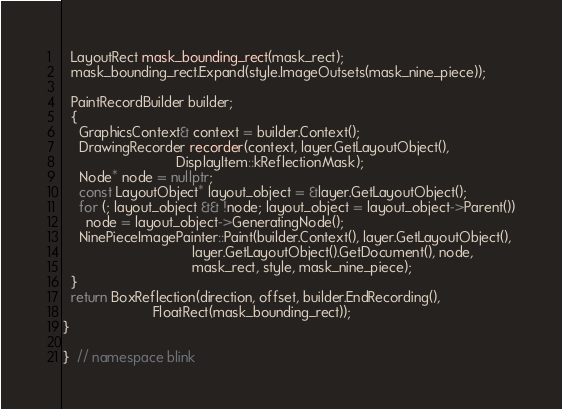<code> <loc_0><loc_0><loc_500><loc_500><_C++_>  LayoutRect mask_bounding_rect(mask_rect);
  mask_bounding_rect.Expand(style.ImageOutsets(mask_nine_piece));

  PaintRecordBuilder builder;
  {
    GraphicsContext& context = builder.Context();
    DrawingRecorder recorder(context, layer.GetLayoutObject(),
                             DisplayItem::kReflectionMask);
    Node* node = nullptr;
    const LayoutObject* layout_object = &layer.GetLayoutObject();
    for (; layout_object && !node; layout_object = layout_object->Parent())
      node = layout_object->GeneratingNode();
    NinePieceImagePainter::Paint(builder.Context(), layer.GetLayoutObject(),
                                 layer.GetLayoutObject().GetDocument(), node,
                                 mask_rect, style, mask_nine_piece);
  }
  return BoxReflection(direction, offset, builder.EndRecording(),
                       FloatRect(mask_bounding_rect));
}

}  // namespace blink
</code> 